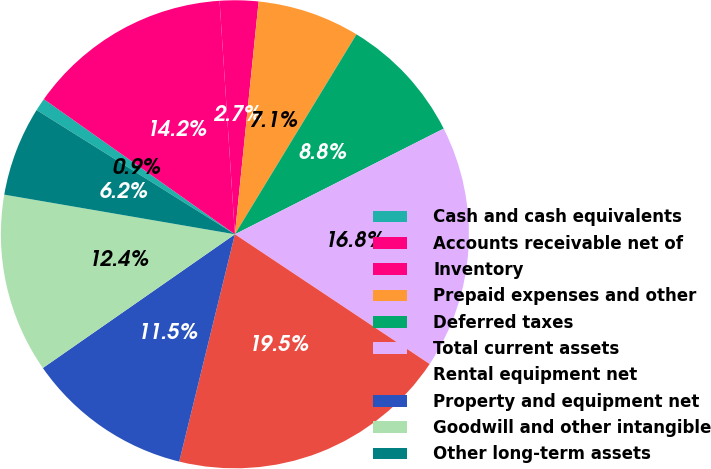<chart> <loc_0><loc_0><loc_500><loc_500><pie_chart><fcel>Cash and cash equivalents<fcel>Accounts receivable net of<fcel>Inventory<fcel>Prepaid expenses and other<fcel>Deferred taxes<fcel>Total current assets<fcel>Rental equipment net<fcel>Property and equipment net<fcel>Goodwill and other intangible<fcel>Other long-term assets<nl><fcel>0.89%<fcel>14.16%<fcel>2.66%<fcel>7.08%<fcel>8.85%<fcel>16.81%<fcel>19.47%<fcel>11.5%<fcel>12.39%<fcel>6.2%<nl></chart> 